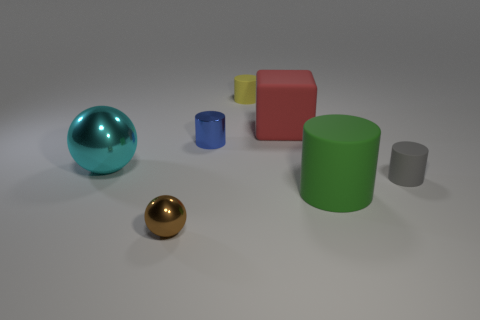Add 3 matte cylinders. How many objects exist? 10 Subtract all tiny yellow cylinders. How many cylinders are left? 3 Subtract 2 spheres. How many spheres are left? 0 Subtract all blocks. How many objects are left? 6 Add 3 brown metal cylinders. How many brown metal cylinders exist? 3 Subtract all blue cylinders. How many cylinders are left? 3 Subtract 1 gray cylinders. How many objects are left? 6 Subtract all green cubes. Subtract all brown cylinders. How many cubes are left? 1 Subtract all large gray spheres. Subtract all spheres. How many objects are left? 5 Add 4 rubber blocks. How many rubber blocks are left? 5 